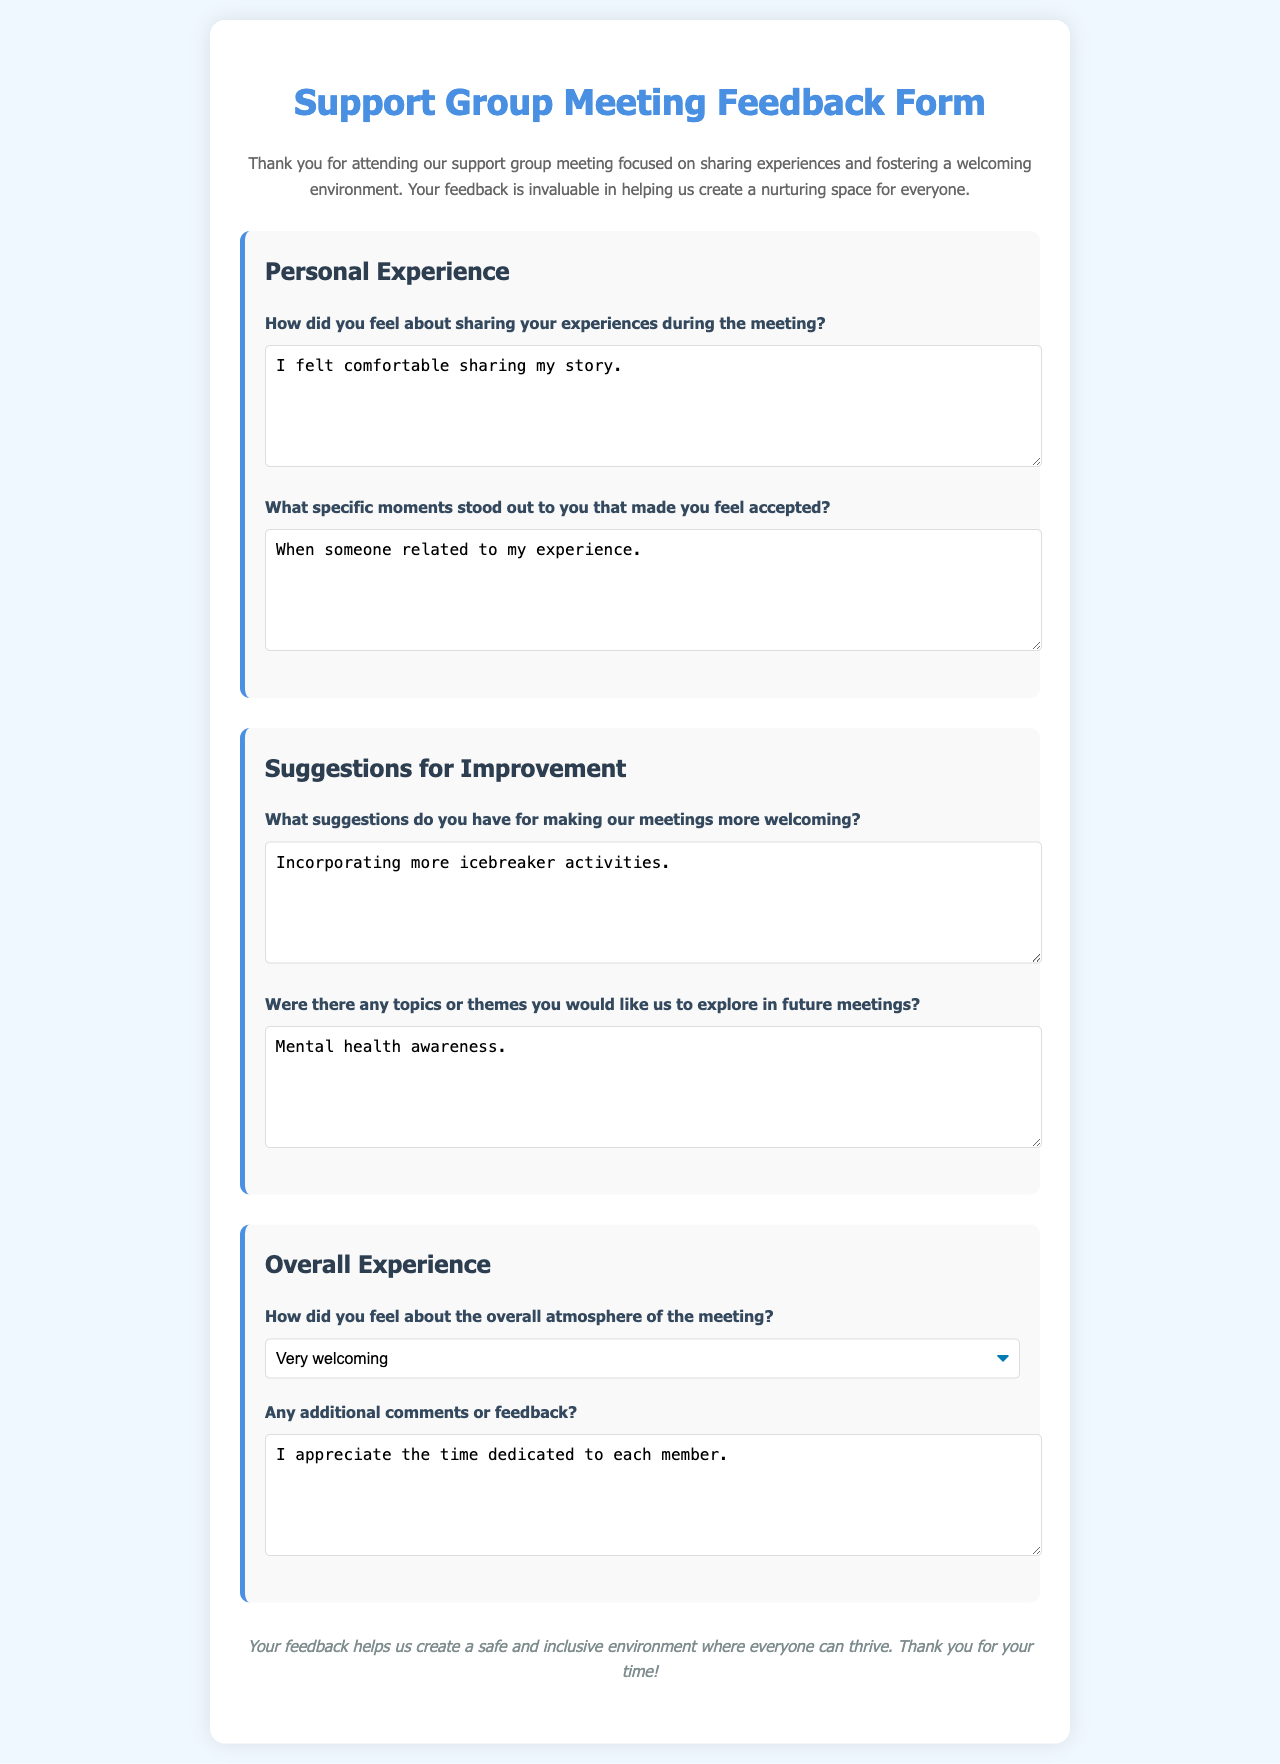How did you feel about sharing your experiences during the meeting? The document contains a specific question asking attendees about their feelings regarding sharing experiences, which invites a personal response.
Answer: I felt comfortable sharing my story What suggestions do you have for making our meetings more welcoming? This question in the document seeks feedback on improvements to foster a welcoming environment, reflecting the essence of the support group.
Answer: Incorporating more icebreaker activities What specific moments stood out to you that made you feel accepted? The document prompts participants to recall particular moments that contributed to their sense of acceptance, highlighting shared experiences.
Answer: When someone related to my experience How did you feel about the overall atmosphere of the meeting? The document includes a section for feedback about the meeting's atmosphere, indicating the importance of this aspect in the support group setting.
Answer: Very welcoming Were there any topics or themes you would like us to explore in future meetings? This question invites participants to express their interests in future discussions, emphasizing engagement in the support group.
Answer: Mental health awareness 